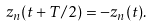<formula> <loc_0><loc_0><loc_500><loc_500>z _ { n } ( t + T / 2 ) = - z _ { n } ( t ) .</formula> 